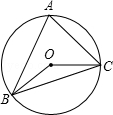In the given figure, triangle ABC is inscribed in circle O with angle A measuring 60.0 degrees. Determine the measure of angle BOC, denoted as θ. In the intriguing world of geometry, every shape and angle tells a story of symmetry and balance. The figure presents us with a delightful puzzle: a triangle ABC that's perfectly inscribed within circle O, harmoniously balanced at all vertices. To solve for angle BOC, often referred to by the Greek letter θ, we focus on the elegant principle that the inscribed angle (angle A) is precisely half of the central angle that subtends the same arc (the angle we're seeking). So, when angle A at the circle's edge measures 60 degrees, the central angle BOC is double that, which is 120 degrees. This is a testament to the sublime consistency of circular geometry, and it's option B that captures this geometric truth. 